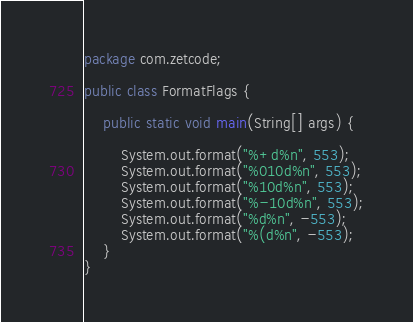<code> <loc_0><loc_0><loc_500><loc_500><_Java_>package com.zetcode;

public class FormatFlags {

    public static void main(String[] args) {
        
        System.out.format("%+d%n", 553);
        System.out.format("%010d%n", 553);
        System.out.format("%10d%n", 553);
        System.out.format("%-10d%n", 553);
        System.out.format("%d%n", -553);
        System.out.format("%(d%n", -553); 
    }
}
</code> 